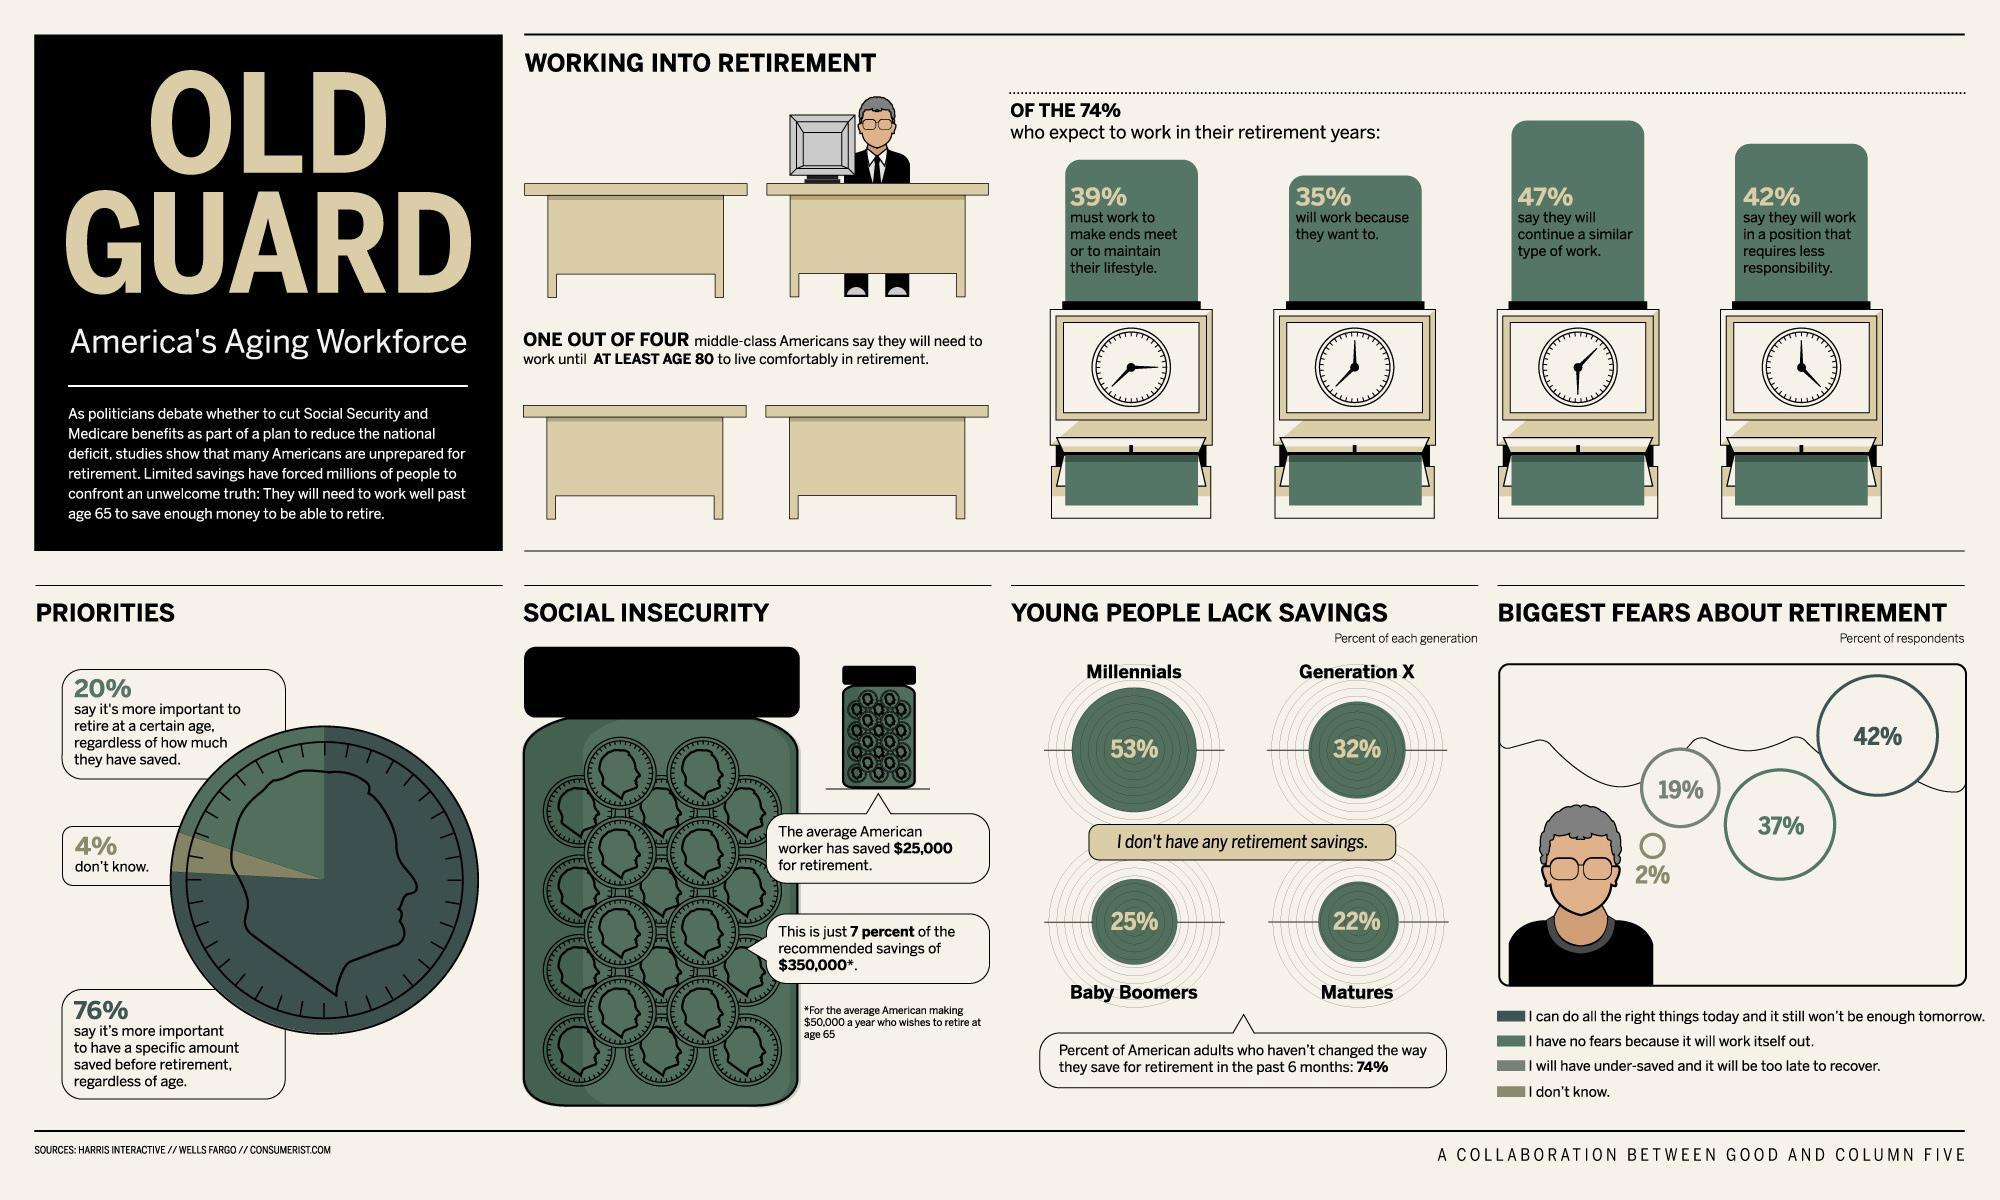What percent of baby boomers in America don't have any retirement savings?
Answer the question with a short phrase. 25% What percent of Americans say that they will continue a similar type of work after their retirement? 47% What percent of Americans say that they will work in a position that requires less responsibility after their retirement? 42% 